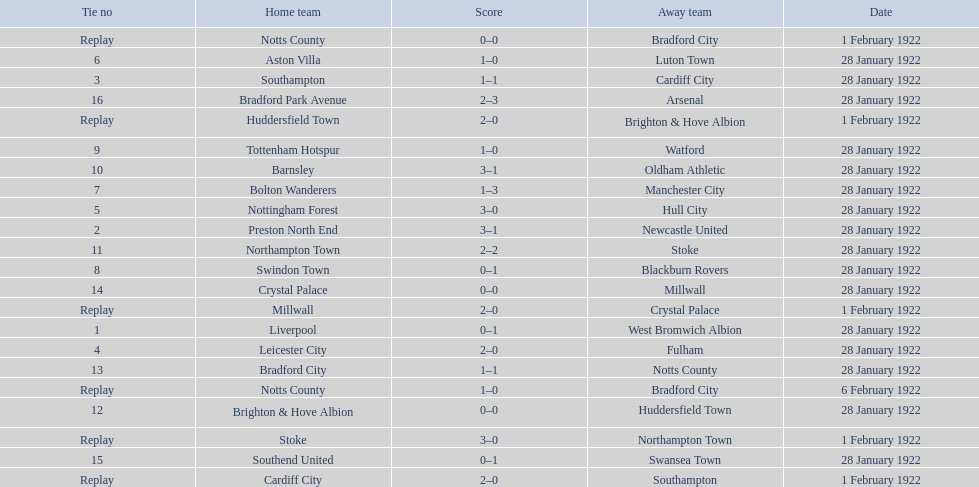What home team had the same score as aston villa on january 28th, 1922? Tottenham Hotspur. 